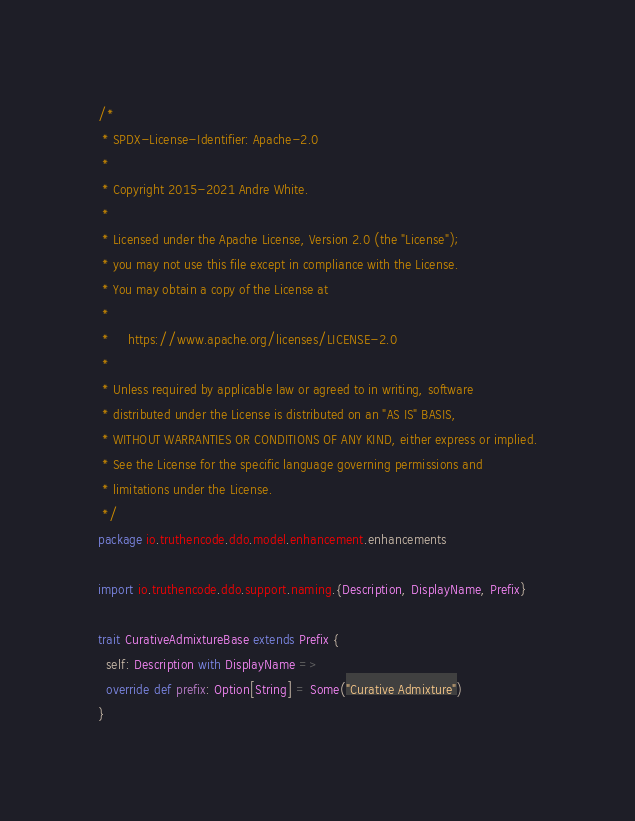<code> <loc_0><loc_0><loc_500><loc_500><_Scala_>/*
 * SPDX-License-Identifier: Apache-2.0
 *
 * Copyright 2015-2021 Andre White.
 *
 * Licensed under the Apache License, Version 2.0 (the "License");
 * you may not use this file except in compliance with the License.
 * You may obtain a copy of the License at
 *
 *     https://www.apache.org/licenses/LICENSE-2.0
 *
 * Unless required by applicable law or agreed to in writing, software
 * distributed under the License is distributed on an "AS IS" BASIS,
 * WITHOUT WARRANTIES OR CONDITIONS OF ANY KIND, either express or implied.
 * See the License for the specific language governing permissions and
 * limitations under the License.
 */
package io.truthencode.ddo.model.enhancement.enhancements

import io.truthencode.ddo.support.naming.{Description, DisplayName, Prefix}

trait CurativeAdmixtureBase extends Prefix {
  self: Description with DisplayName =>
  override def prefix: Option[String] = Some("Curative Admixture")
}
</code> 